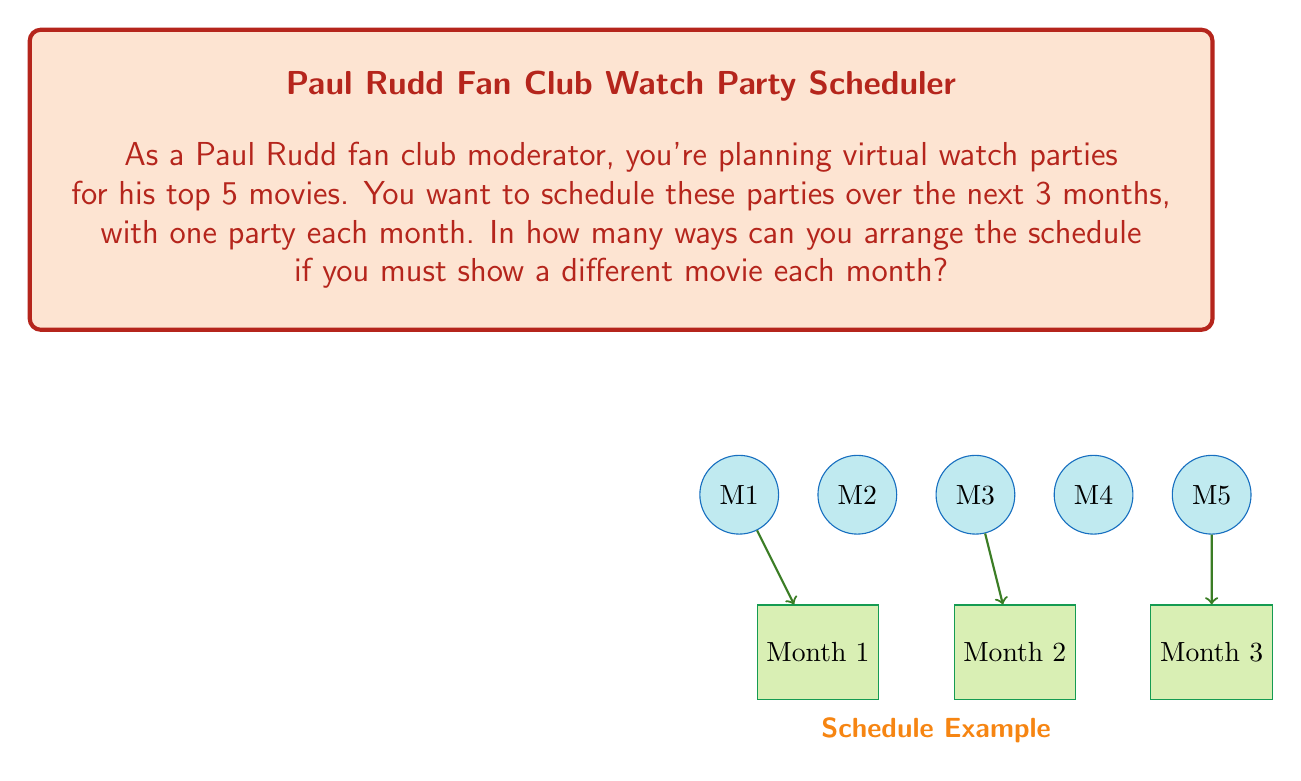Show me your answer to this math problem. Let's approach this step-by-step:

1) We have 5 movies to choose from for the first month. Let's call this choice $n_1$.
   $$n_1 = 5$$

2) After selecting a movie for the first month, we have 4 movies left for the second month. Let's call this choice $n_2$.
   $$n_2 = 4$$

3) For the third month, we're left with 3 movies to choose from. Let's call this choice $n_3$.
   $$n_3 = 3$$

4) This scenario follows the multiplication principle of counting. The total number of ways to make these choices is the product of the number of ways to make each individual choice.

5) Therefore, the total number of possible schedules is:
   $$n_1 \times n_2 \times n_3 = 5 \times 4 \times 3 = 60$$

This is equivalent to the permutation formula:
$$P(5,3) = \frac{5!}{(5-3)!} = \frac{5!}{2!} = 60$$

Where we're selecting 3 movies from 5, with order being important (as the order of months matters).
Answer: 60 